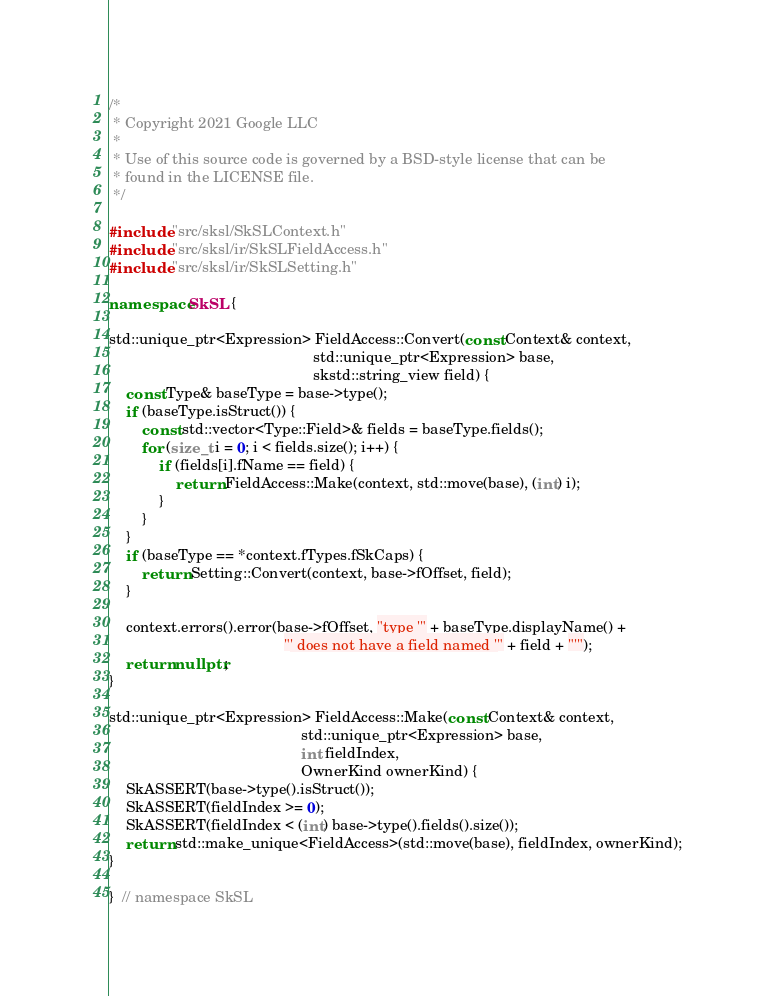Convert code to text. <code><loc_0><loc_0><loc_500><loc_500><_C++_>/*
 * Copyright 2021 Google LLC
 *
 * Use of this source code is governed by a BSD-style license that can be
 * found in the LICENSE file.
 */

#include "src/sksl/SkSLContext.h"
#include "src/sksl/ir/SkSLFieldAccess.h"
#include "src/sksl/ir/SkSLSetting.h"

namespace SkSL {

std::unique_ptr<Expression> FieldAccess::Convert(const Context& context,
                                                 std::unique_ptr<Expression> base,
                                                 skstd::string_view field) {
    const Type& baseType = base->type();
    if (baseType.isStruct()) {
        const std::vector<Type::Field>& fields = baseType.fields();
        for (size_t i = 0; i < fields.size(); i++) {
            if (fields[i].fName == field) {
                return FieldAccess::Make(context, std::move(base), (int) i);
            }
        }
    }
    if (baseType == *context.fTypes.fSkCaps) {
        return Setting::Convert(context, base->fOffset, field);
    }

    context.errors().error(base->fOffset, "type '" + baseType.displayName() +
                                          "' does not have a field named '" + field + "'");
    return nullptr;
}

std::unique_ptr<Expression> FieldAccess::Make(const Context& context,
                                              std::unique_ptr<Expression> base,
                                              int fieldIndex,
                                              OwnerKind ownerKind) {
    SkASSERT(base->type().isStruct());
    SkASSERT(fieldIndex >= 0);
    SkASSERT(fieldIndex < (int) base->type().fields().size());
    return std::make_unique<FieldAccess>(std::move(base), fieldIndex, ownerKind);
}

}  // namespace SkSL
</code> 